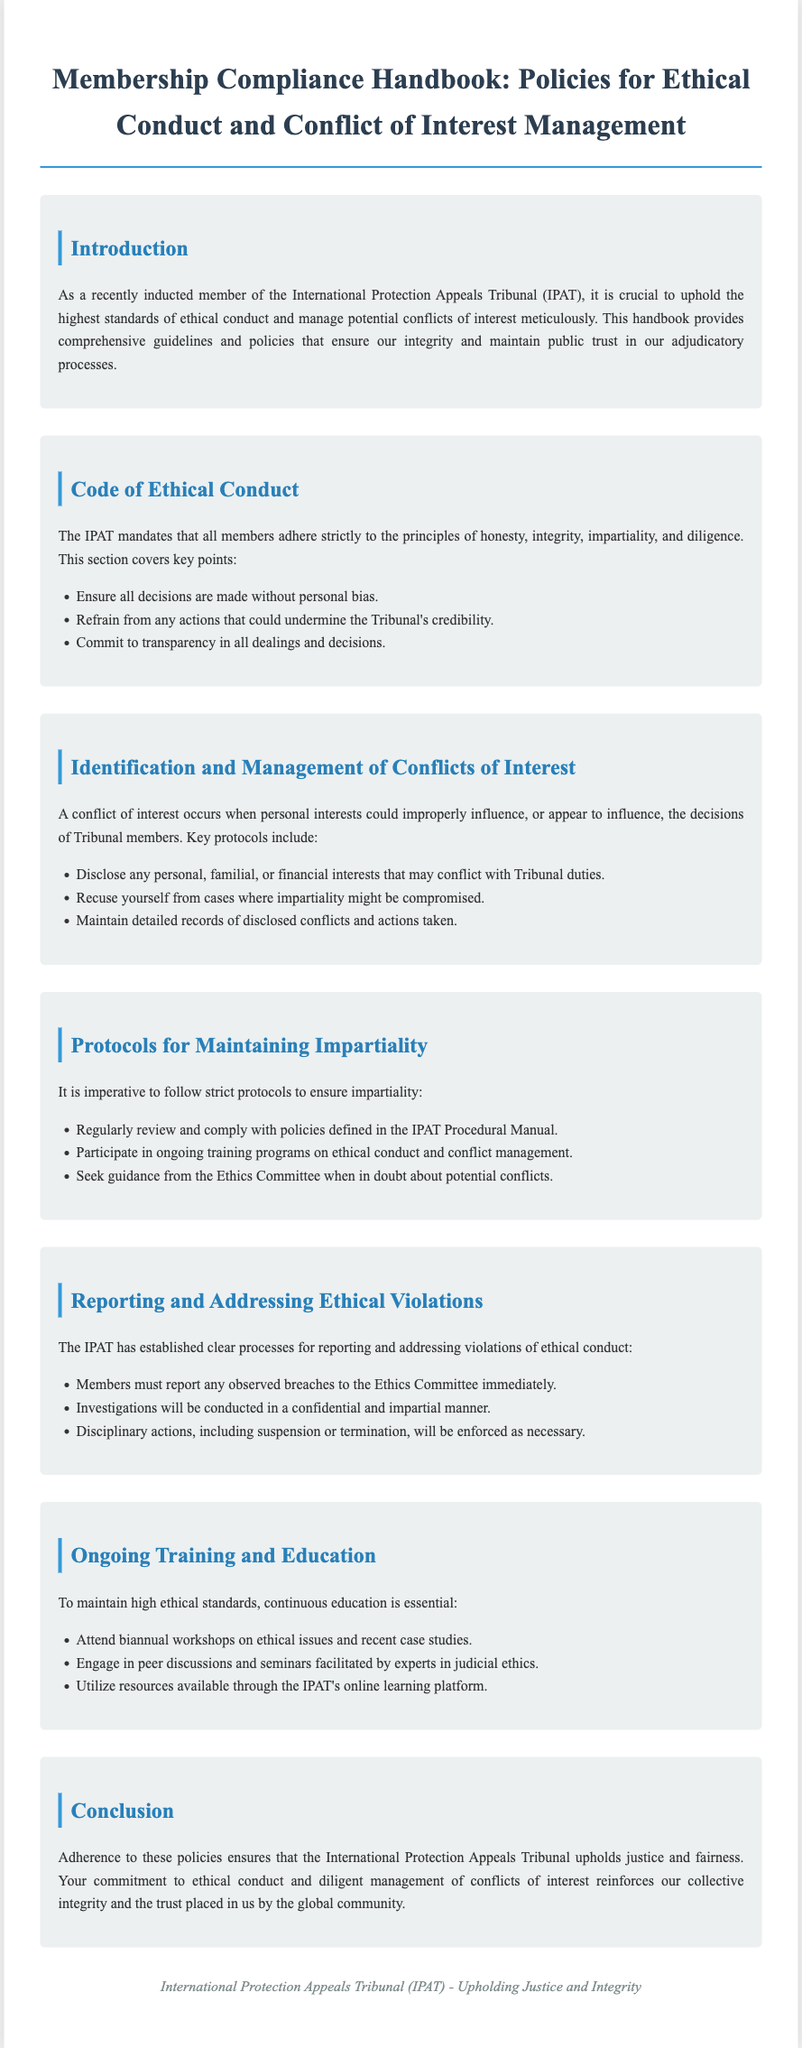What is the title of the handbook? The title is stated clearly in the header of the document, which is focused on policies for ethical conduct and conflict of interest management.
Answer: Membership Compliance Handbook: Policies for Ethical Conduct and Conflict of Interest Management What must members adhere to according to the Code of Ethical Conduct? The document outlines key principles that members are mandated to uphold, which include integrity and impartiality.
Answer: Principles of honesty, integrity, impartiality, and diligence What should members disclose to manage conflicts of interest? The section on conflicts of interest specifies what should be disclosed to avoid improper influence on decisions.
Answer: Personal, familial, or financial interests What is the consequence of observed ethical violations? The document mentions actions that can be taken against members who breach ethical conduct, which includes disciplinary measures.
Answer: Suspension or termination How often should members attend workshops on ethical issues? There is a specified frequency for attending ongoing training to ensure high ethical standards are maintained.
Answer: Biannual What is the main focus of the concluded training and education section? The section highlights the importance of continuous education to uphold ethical standards within the Tribunal.
Answer: Continuous education What is the responsibility of the Ethics Committee? The document outlines the role of the Ethics Committee in dealing with reported ethical breaches.
Answer: Conducting investigations What should members do if they are uncertain about potential conflicts? The section on protocols emphasizes the need for guidance in ambiguous situations regarding conflicts of interest.
Answer: Seek guidance from the Ethics Committee What is crucial for maintaining the Tribunal's integrity? The introduction emphasizes the importance of ethical conduct and conflict management in maintaining public trust.
Answer: Uphold the highest standards of ethical conduct 